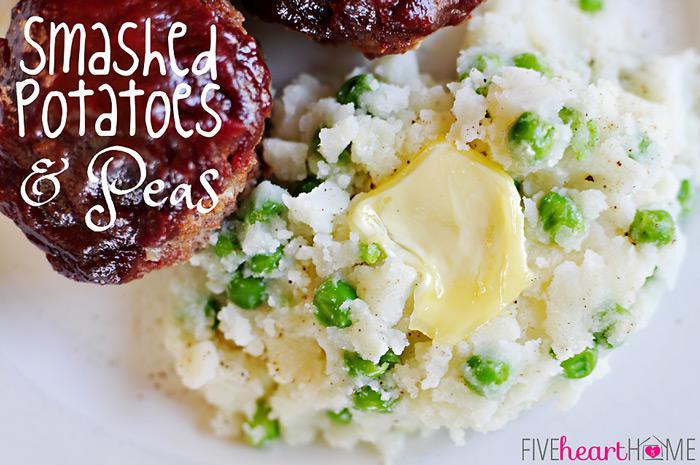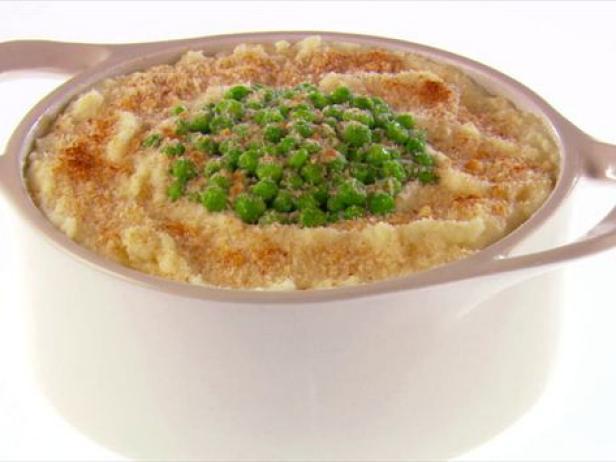The first image is the image on the left, the second image is the image on the right. For the images displayed, is the sentence "In one image a round white bowl of mashed potatoes is garnished with chives, while a second image shows mashed potatoes with a green garnish served in a dark dish." factually correct? Answer yes or no. No. The first image is the image on the left, the second image is the image on the right. For the images shown, is this caption "An image shows a round container of food with green peas in a pile on the very top." true? Answer yes or no. Yes. 